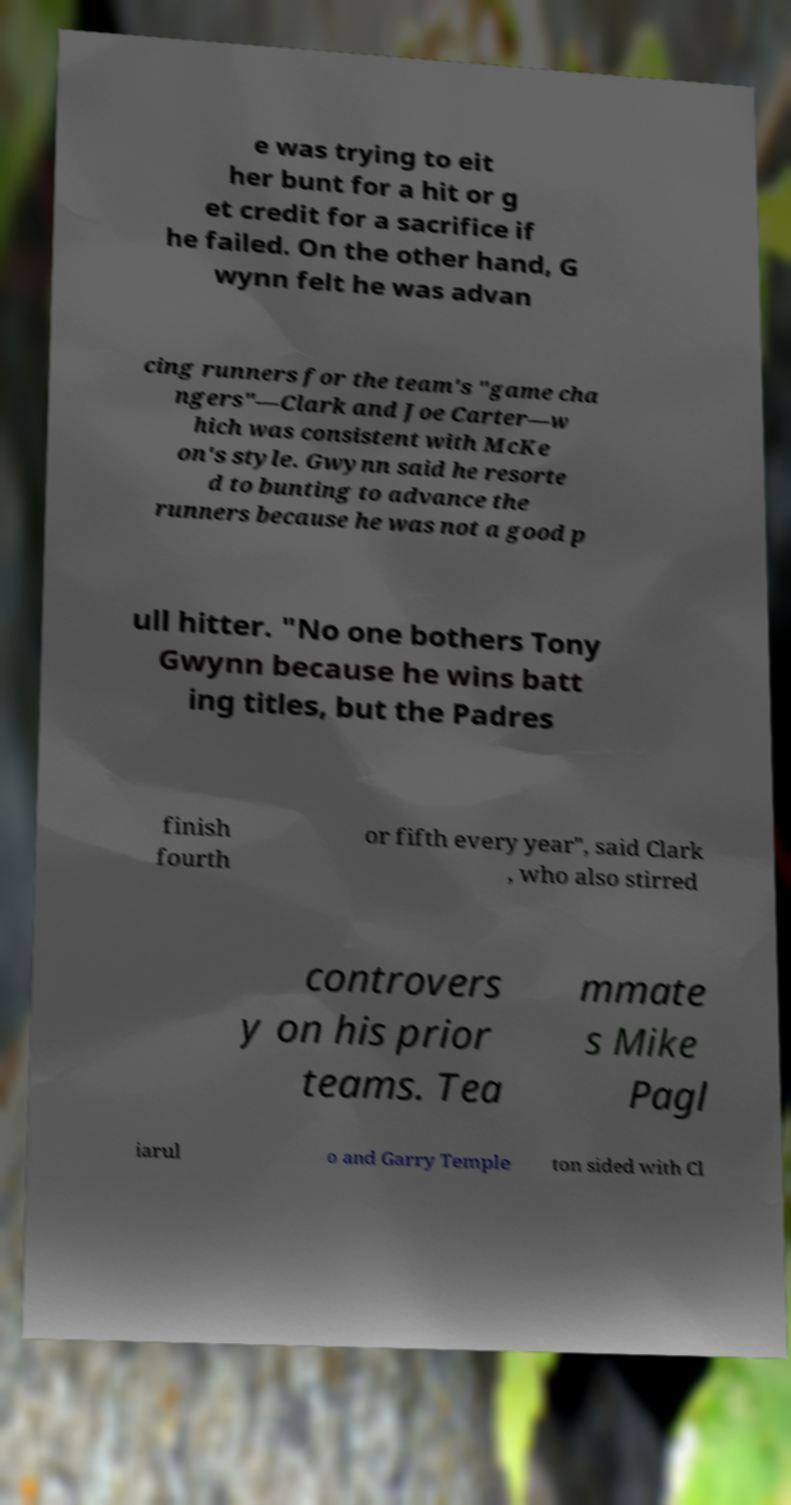There's text embedded in this image that I need extracted. Can you transcribe it verbatim? e was trying to eit her bunt for a hit or g et credit for a sacrifice if he failed. On the other hand, G wynn felt he was advan cing runners for the team's "game cha ngers"—Clark and Joe Carter—w hich was consistent with McKe on's style. Gwynn said he resorte d to bunting to advance the runners because he was not a good p ull hitter. "No one bothers Tony Gwynn because he wins batt ing titles, but the Padres finish fourth or fifth every year", said Clark , who also stirred controvers y on his prior teams. Tea mmate s Mike Pagl iarul o and Garry Temple ton sided with Cl 